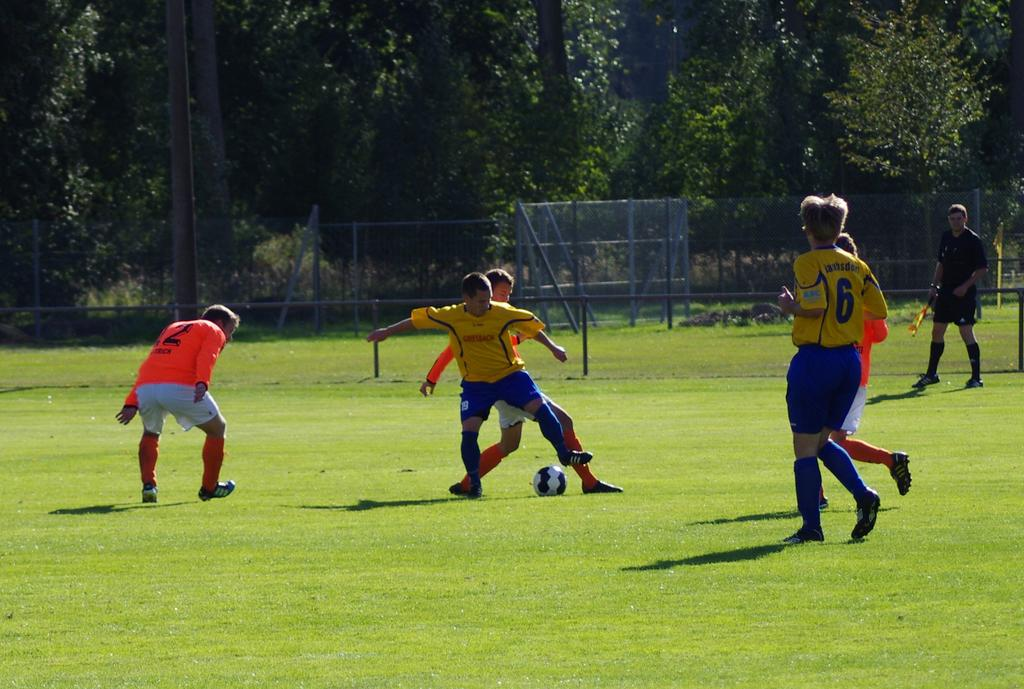<image>
Relay a brief, clear account of the picture shown. number 6 in a yellow jersey is playing soccer with other men 